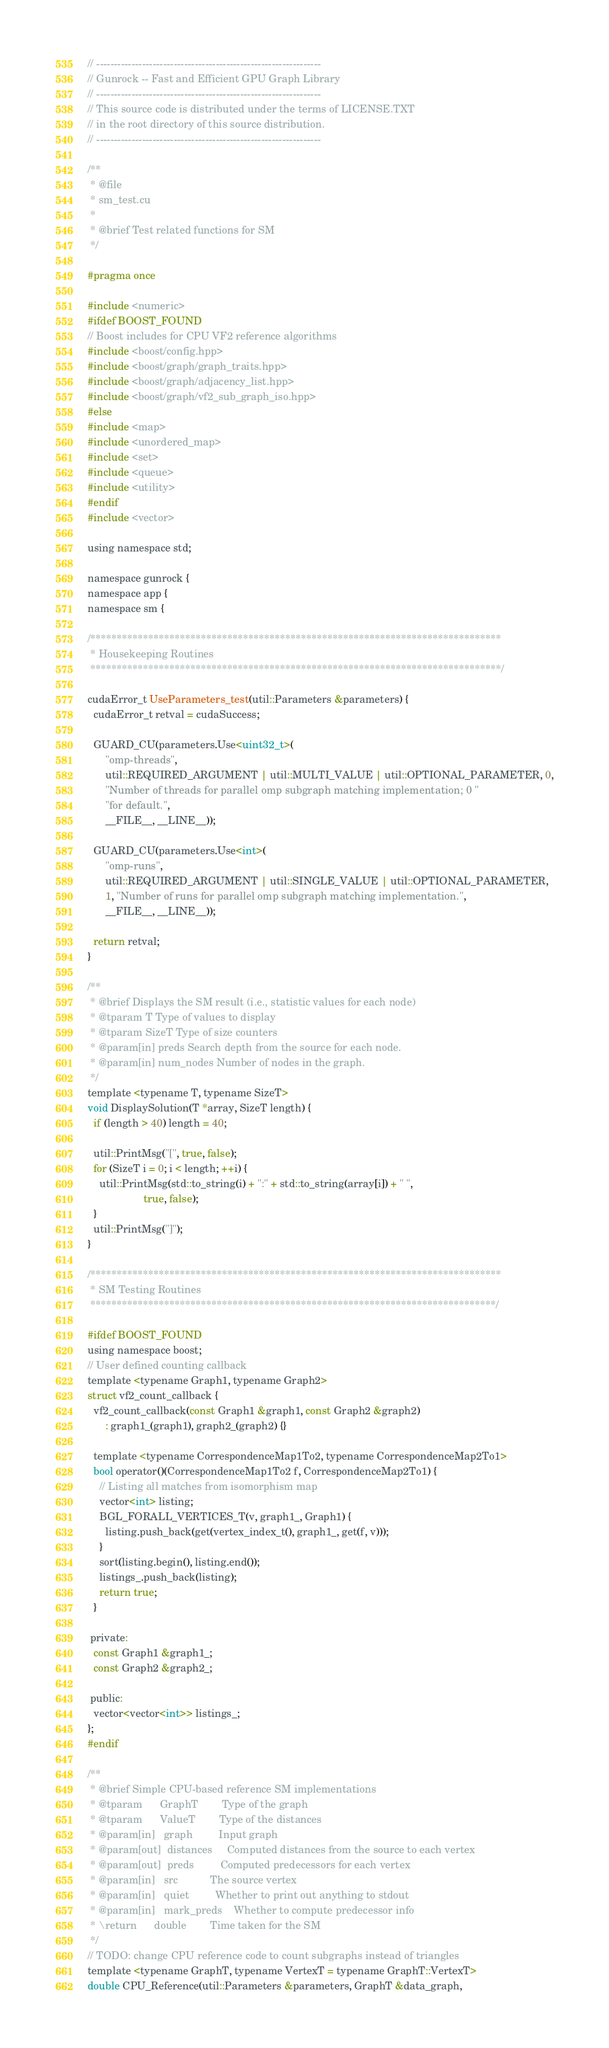<code> <loc_0><loc_0><loc_500><loc_500><_Cuda_>// ----------------------------------------------------------------
// Gunrock -- Fast and Efficient GPU Graph Library
// ----------------------------------------------------------------
// This source code is distributed under the terms of LICENSE.TXT
// in the root directory of this source distribution.
// ----------------------------------------------------------------

/**
 * @file
 * sm_test.cu
 *
 * @brief Test related functions for SM
 */

#pragma once

#include <numeric>
#ifdef BOOST_FOUND
// Boost includes for CPU VF2 reference algorithms
#include <boost/config.hpp>
#include <boost/graph/graph_traits.hpp>
#include <boost/graph/adjacency_list.hpp>
#include <boost/graph/vf2_sub_graph_iso.hpp>
#else
#include <map>
#include <unordered_map>
#include <set>
#include <queue>
#include <utility>
#endif
#include <vector>

using namespace std;

namespace gunrock {
namespace app {
namespace sm {

/******************************************************************************
 * Housekeeping Routines
 ******************************************************************************/

cudaError_t UseParameters_test(util::Parameters &parameters) {
  cudaError_t retval = cudaSuccess;

  GUARD_CU(parameters.Use<uint32_t>(
      "omp-threads",
      util::REQUIRED_ARGUMENT | util::MULTI_VALUE | util::OPTIONAL_PARAMETER, 0,
      "Number of threads for parallel omp subgraph matching implementation; 0 "
      "for default.",
      __FILE__, __LINE__));

  GUARD_CU(parameters.Use<int>(
      "omp-runs",
      util::REQUIRED_ARGUMENT | util::SINGLE_VALUE | util::OPTIONAL_PARAMETER,
      1, "Number of runs for parallel omp subgraph matching implementation.",
      __FILE__, __LINE__));

  return retval;
}

/**
 * @brief Displays the SM result (i.e., statistic values for each node)
 * @tparam T Type of values to display
 * @tparam SizeT Type of size counters
 * @param[in] preds Search depth from the source for each node.
 * @param[in] num_nodes Number of nodes in the graph.
 */
template <typename T, typename SizeT>
void DisplaySolution(T *array, SizeT length) {
  if (length > 40) length = 40;

  util::PrintMsg("[", true, false);
  for (SizeT i = 0; i < length; ++i) {
    util::PrintMsg(std::to_string(i) + ":" + std::to_string(array[i]) + " ",
                   true, false);
  }
  util::PrintMsg("]");
}

/******************************************************************************
 * SM Testing Routines
 *****************************************************************************/

#ifdef BOOST_FOUND
using namespace boost;
// User defined counting callback
template <typename Graph1, typename Graph2>
struct vf2_count_callback {
  vf2_count_callback(const Graph1 &graph1, const Graph2 &graph2)
      : graph1_(graph1), graph2_(graph2) {}

  template <typename CorrespondenceMap1To2, typename CorrespondenceMap2To1>
  bool operator()(CorrespondenceMap1To2 f, CorrespondenceMap2To1) {
    // Listing all matches from isomorphism map
    vector<int> listing;
    BGL_FORALL_VERTICES_T(v, graph1_, Graph1) {
      listing.push_back(get(vertex_index_t(), graph1_, get(f, v)));
    }
    sort(listing.begin(), listing.end());
    listings_.push_back(listing);
    return true;
  }

 private:
  const Graph1 &graph1_;
  const Graph2 &graph2_;

 public:
  vector<vector<int>> listings_;
};
#endif

/**
 * @brief Simple CPU-based reference SM implementations
 * @tparam      GraphT        Type of the graph
 * @tparam      ValueT        Type of the distances
 * @param[in]   graph         Input graph
 * @param[out]  distances     Computed distances from the source to each vertex
 * @param[out]  preds         Computed predecessors for each vertex
 * @param[in]   src           The source vertex
 * @param[in]   quiet         Whether to print out anything to stdout
 * @param[in]   mark_preds    Whether to compute predecessor info
 * \return      double        Time taken for the SM
 */
// TODO: change CPU reference code to count subgraphs instead of triangles
template <typename GraphT, typename VertexT = typename GraphT::VertexT>
double CPU_Reference(util::Parameters &parameters, GraphT &data_graph,</code> 